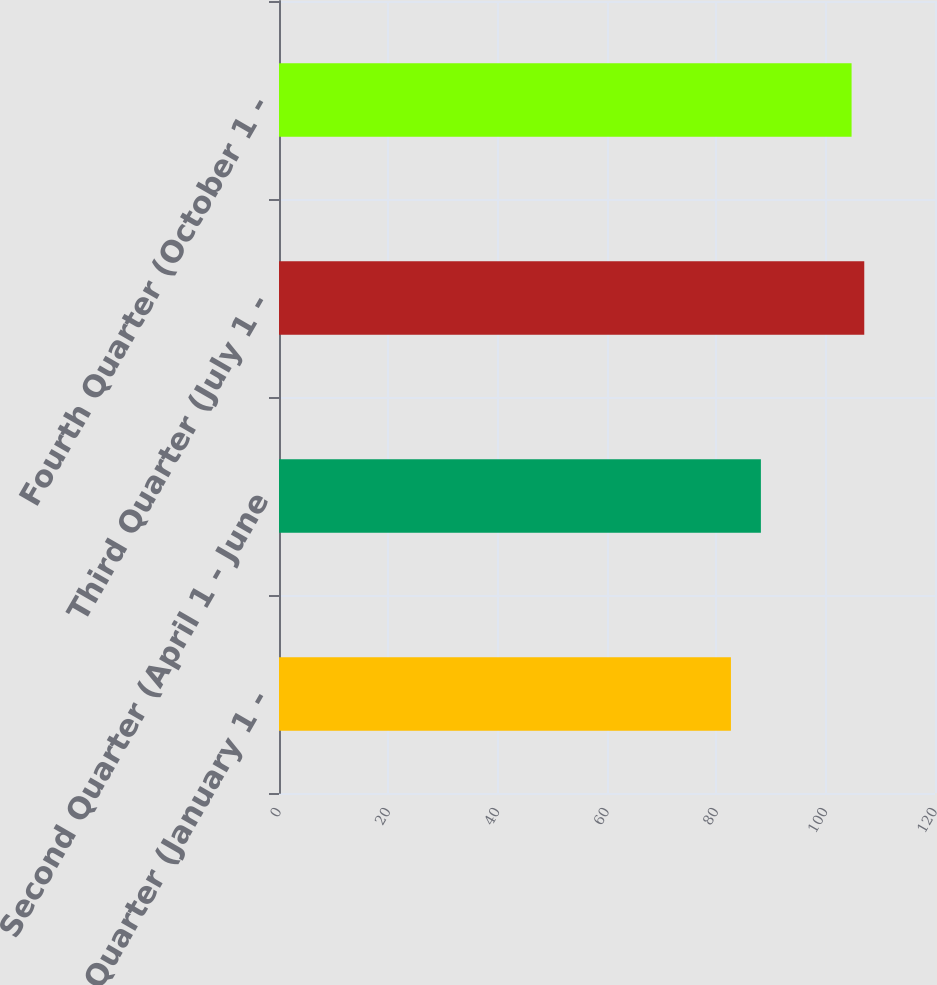Convert chart to OTSL. <chart><loc_0><loc_0><loc_500><loc_500><bar_chart><fcel>First Quarter (January 1 -<fcel>Second Quarter (April 1 - June<fcel>Third Quarter (July 1 -<fcel>Fourth Quarter (October 1 -<nl><fcel>82.67<fcel>88.15<fcel>107.06<fcel>104.74<nl></chart> 